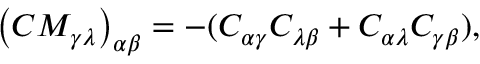Convert formula to latex. <formula><loc_0><loc_0><loc_500><loc_500>\left ( C M _ { \gamma \lambda } \right ) _ { \alpha \beta } = - ( C _ { \alpha \gamma } C _ { \lambda \beta } + C _ { \alpha \lambda } C _ { \gamma \beta } ) ,</formula> 